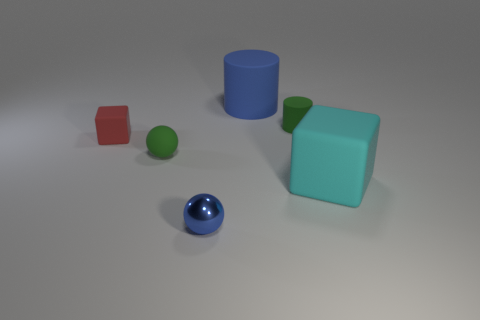Is there any other thing that has the same material as the blue sphere?
Your answer should be very brief. No. What is the material of the object that is both in front of the tiny green sphere and to the right of the small metallic sphere?
Provide a succinct answer. Rubber. Does the small object that is in front of the cyan matte cube have the same shape as the blue rubber object?
Make the answer very short. No. Are there fewer cubes than blue rubber cylinders?
Your answer should be very brief. No. What number of small matte cylinders have the same color as the rubber ball?
Your answer should be compact. 1. There is a ball that is the same color as the tiny cylinder; what material is it?
Offer a very short reply. Rubber. There is a small metal sphere; is its color the same as the large matte object that is behind the tiny red object?
Offer a very short reply. Yes. Is the number of matte balls greater than the number of large objects?
Provide a short and direct response. No. What size is the green object that is the same shape as the blue shiny object?
Provide a short and direct response. Small. Is the large cyan block made of the same material as the tiny ball in front of the large cyan block?
Provide a short and direct response. No. 